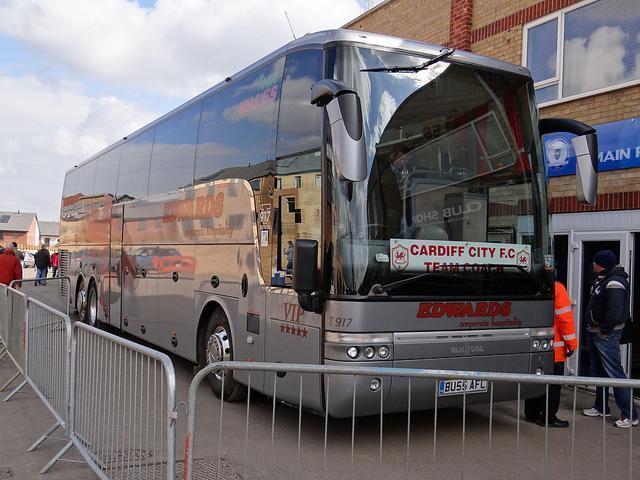How many people are standing outside of the bus?
Give a very brief answer. 2. How many buses are there?
Give a very brief answer. 1. How many people are there?
Give a very brief answer. 2. 